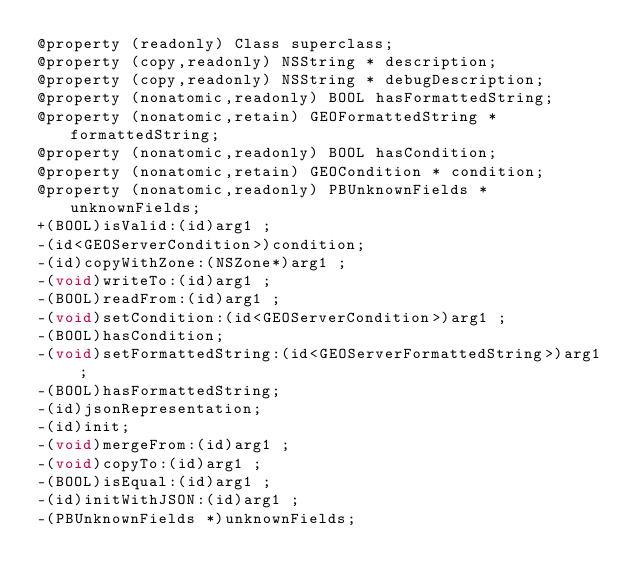<code> <loc_0><loc_0><loc_500><loc_500><_C_>@property (readonly) Class superclass; 
@property (copy,readonly) NSString * description; 
@property (copy,readonly) NSString * debugDescription; 
@property (nonatomic,readonly) BOOL hasFormattedString; 
@property (nonatomic,retain) GEOFormattedString * formattedString; 
@property (nonatomic,readonly) BOOL hasCondition; 
@property (nonatomic,retain) GEOCondition * condition; 
@property (nonatomic,readonly) PBUnknownFields * unknownFields; 
+(BOOL)isValid:(id)arg1 ;
-(id<GEOServerCondition>)condition;
-(id)copyWithZone:(NSZone*)arg1 ;
-(void)writeTo:(id)arg1 ;
-(BOOL)readFrom:(id)arg1 ;
-(void)setCondition:(id<GEOServerCondition>)arg1 ;
-(BOOL)hasCondition;
-(void)setFormattedString:(id<GEOServerFormattedString>)arg1 ;
-(BOOL)hasFormattedString;
-(id)jsonRepresentation;
-(id)init;
-(void)mergeFrom:(id)arg1 ;
-(void)copyTo:(id)arg1 ;
-(BOOL)isEqual:(id)arg1 ;
-(id)initWithJSON:(id)arg1 ;
-(PBUnknownFields *)unknownFields;</code> 